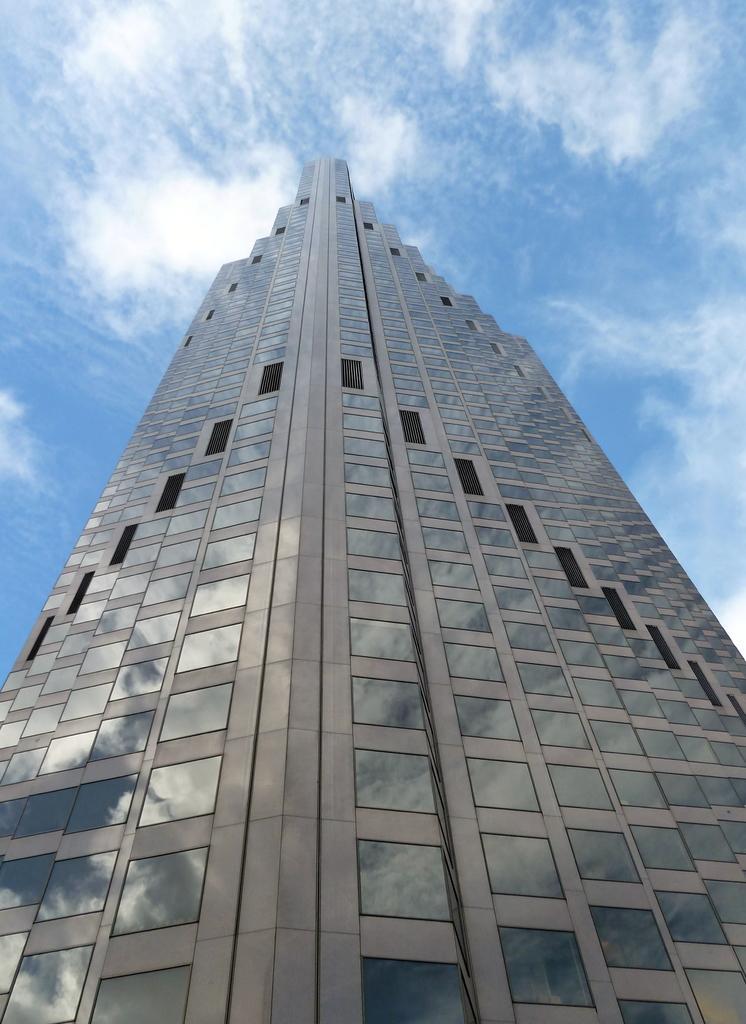How would you summarize this image in a sentence or two? In this image there is a building and the sky is cloudy. 